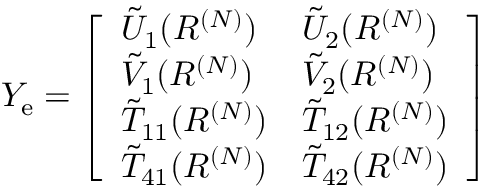<formula> <loc_0><loc_0><loc_500><loc_500>\begin{array} { r } { Y _ { e } = \left [ \begin{array} { l l } { \tilde { U } _ { 1 } ( R ^ { ( N ) } ) } & { \tilde { U } _ { 2 } ( R ^ { ( N ) } ) } \\ { \tilde { V } _ { 1 } ( R ^ { ( N ) } ) } & { \tilde { V } _ { 2 } ( R ^ { ( N ) } ) } \\ { \tilde { T } _ { 1 1 } ( R ^ { ( N ) } ) } & { \tilde { T } _ { 1 2 } ( R ^ { ( N ) } ) } \\ { \tilde { T } _ { 4 1 } ( R ^ { ( N ) } ) } & { \tilde { T } _ { 4 2 } ( R ^ { ( N ) } ) } \end{array} \right ] } \end{array}</formula> 